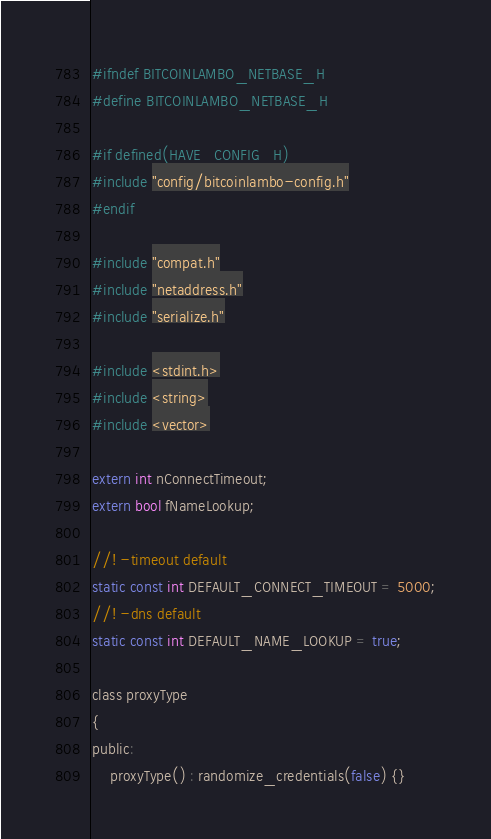Convert code to text. <code><loc_0><loc_0><loc_500><loc_500><_C_>
#ifndef BITCOINLAMBO_NETBASE_H
#define BITCOINLAMBO_NETBASE_H

#if defined(HAVE_CONFIG_H)
#include "config/bitcoinlambo-config.h"
#endif

#include "compat.h"
#include "netaddress.h"
#include "serialize.h"

#include <stdint.h>
#include <string>
#include <vector>

extern int nConnectTimeout;
extern bool fNameLookup;

//! -timeout default
static const int DEFAULT_CONNECT_TIMEOUT = 5000;
//! -dns default
static const int DEFAULT_NAME_LOOKUP = true;

class proxyType
{
public:
    proxyType() : randomize_credentials(false) {}</code> 